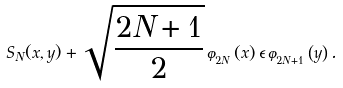Convert formula to latex. <formula><loc_0><loc_0><loc_500><loc_500>S _ { N } ( x , y ) + \sqrt { \frac { 2 N + 1 } { 2 } } \, \varphi _ { _ { 2 N } } \left ( x \right ) \epsilon \, \varphi _ { _ { 2 N + 1 } } \left ( y \right ) .</formula> 